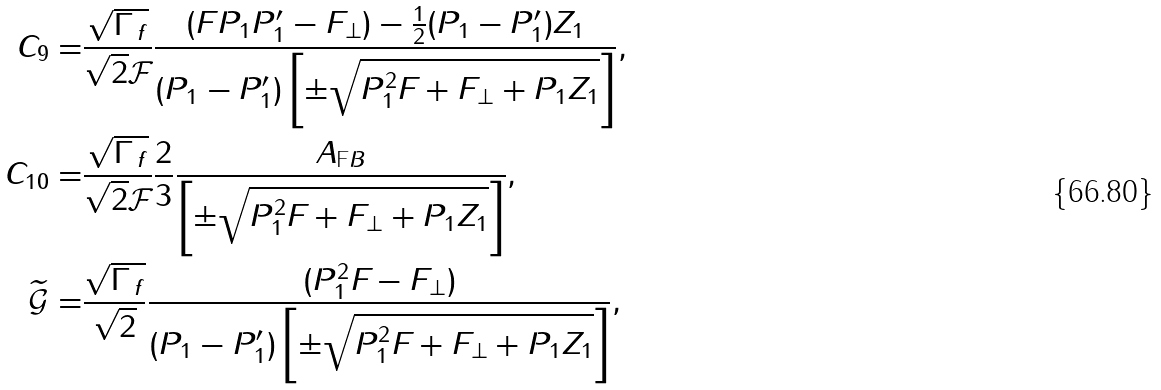Convert formula to latex. <formula><loc_0><loc_0><loc_500><loc_500>C _ { 9 } = & \frac { \sqrt { \Gamma _ { \, f } } } { \sqrt { 2 } \mathcal { F } _ { \| } } \frac { ( F _ { \| } P _ { 1 } P ^ { \prime } _ { 1 } - F _ { \perp } ) - \frac { 1 } { 2 } ( P _ { 1 } - P ^ { \prime } _ { 1 } ) Z _ { 1 } } { ( P _ { 1 } - P ^ { \prime } _ { 1 } ) \left [ \pm \sqrt { P _ { 1 } ^ { 2 } F _ { \| } + F _ { \perp } + P _ { 1 } Z _ { 1 } } \right ] } , \\ C _ { 1 0 } = & \frac { \sqrt { \Gamma _ { \, f } } } { \sqrt { 2 } \mathcal { F } _ { \| } } \frac { 2 } { 3 } \frac { A _ { \text  FB}}{\left[\pm\sqrt{P_{1} ^ { 2 } F _ { \| } + F _ { \perp } + P _ { 1 } Z _ { 1 } } \right ] } , \\ \widetilde { \mathcal { G } } _ { \| } = & \frac { \sqrt { \Gamma _ { \, f } } } { \sqrt { 2 } } \frac { ( P _ { 1 } ^ { 2 } F _ { \| } - F _ { \perp } ) } { ( P _ { 1 } - P ^ { \prime } _ { 1 } ) \left [ \pm \sqrt { P _ { 1 } ^ { 2 } F _ { \| } + F _ { \perp } + P _ { 1 } Z _ { 1 } } \right ] } ,</formula> 